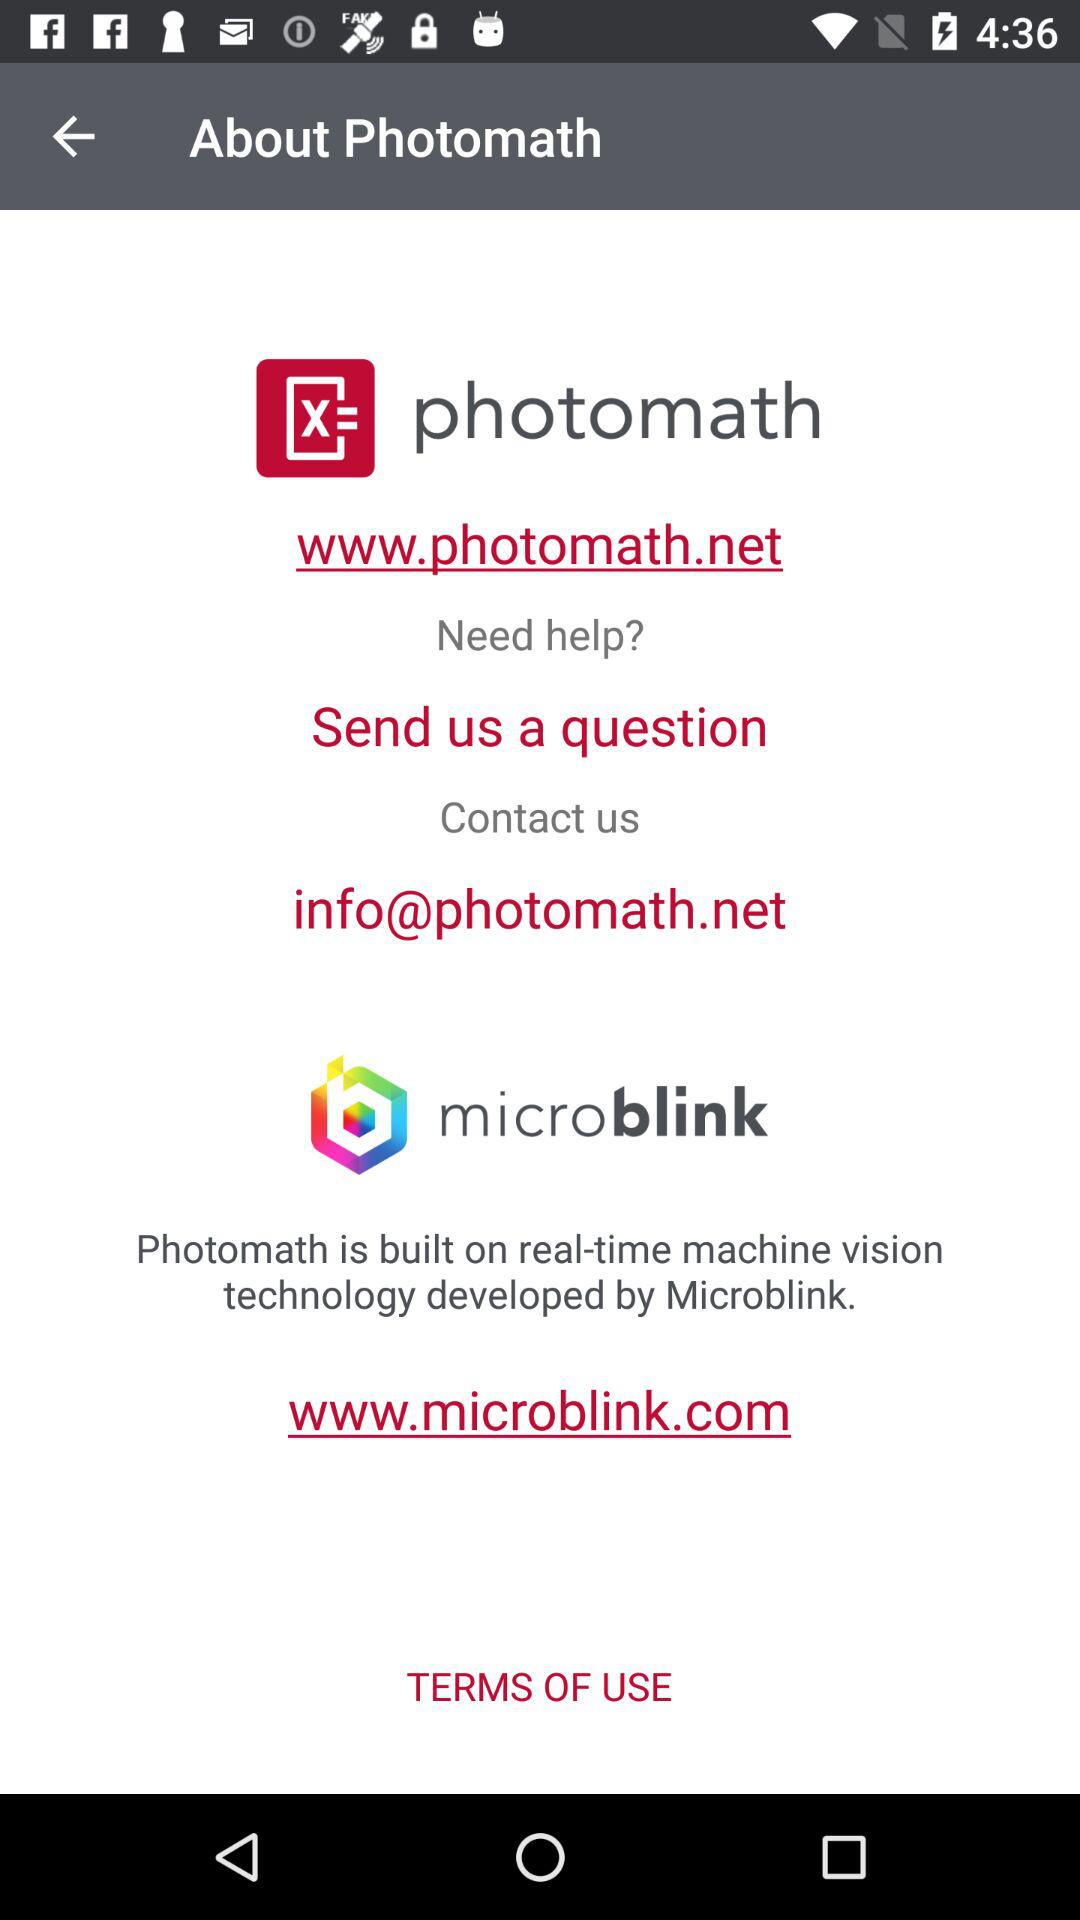Has the user agreed to the terms of use?
When the provided information is insufficient, respond with <no answer>. <no answer> 